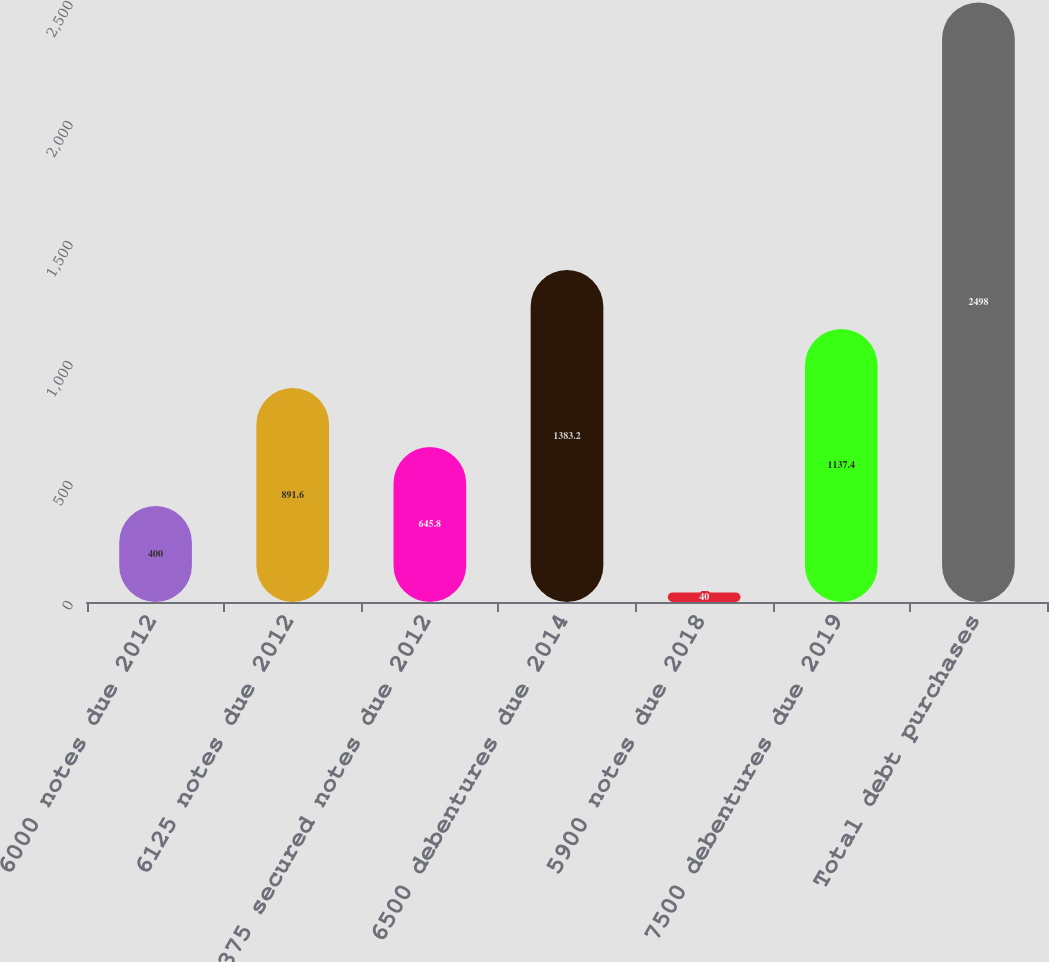<chart> <loc_0><loc_0><loc_500><loc_500><bar_chart><fcel>6000 notes due 2012<fcel>6125 notes due 2012<fcel>8375 secured notes due 2012<fcel>6500 debentures due 2014<fcel>5900 notes due 2018<fcel>7500 debentures due 2019<fcel>Total debt purchases<nl><fcel>400<fcel>891.6<fcel>645.8<fcel>1383.2<fcel>40<fcel>1137.4<fcel>2498<nl></chart> 